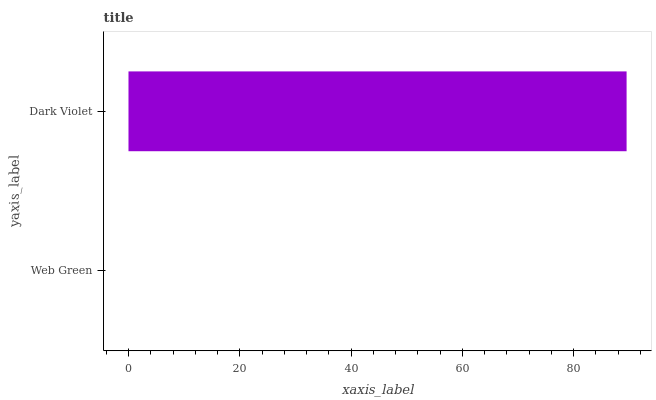Is Web Green the minimum?
Answer yes or no. Yes. Is Dark Violet the maximum?
Answer yes or no. Yes. Is Dark Violet the minimum?
Answer yes or no. No. Is Dark Violet greater than Web Green?
Answer yes or no. Yes. Is Web Green less than Dark Violet?
Answer yes or no. Yes. Is Web Green greater than Dark Violet?
Answer yes or no. No. Is Dark Violet less than Web Green?
Answer yes or no. No. Is Dark Violet the high median?
Answer yes or no. Yes. Is Web Green the low median?
Answer yes or no. Yes. Is Web Green the high median?
Answer yes or no. No. Is Dark Violet the low median?
Answer yes or no. No. 